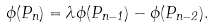<formula> <loc_0><loc_0><loc_500><loc_500>\phi ( P _ { n } ) = \lambda \phi ( P _ { n - 1 } ) - \phi ( P _ { n - 2 } ) .</formula> 